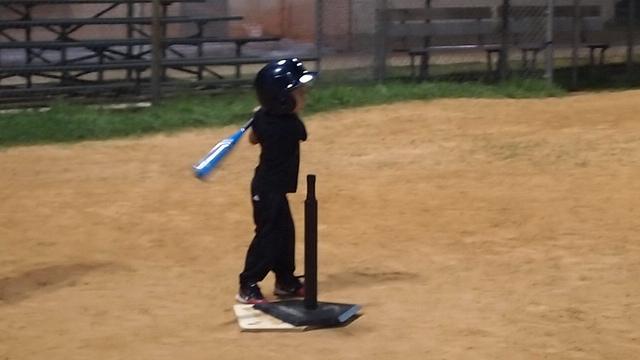What is the boy holding?
Quick response, please. Bat. Is this regular baseball?
Be succinct. No. Is the person swinging the bat?
Concise answer only. Yes. 